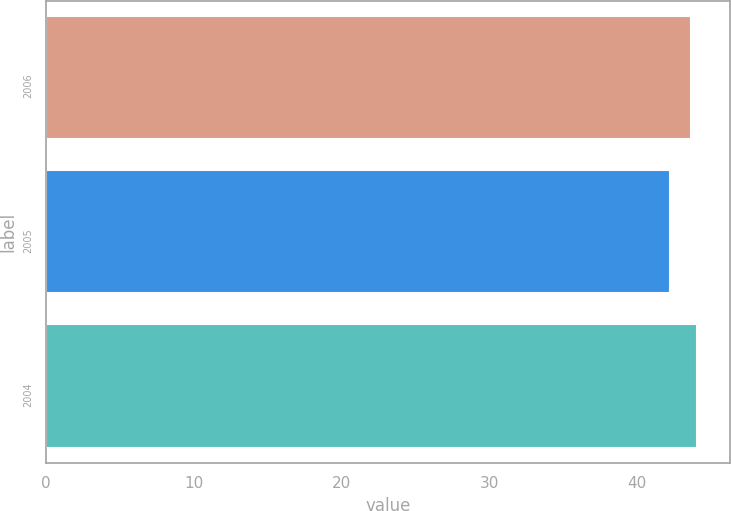<chart> <loc_0><loc_0><loc_500><loc_500><bar_chart><fcel>2006<fcel>2005<fcel>2004<nl><fcel>43.7<fcel>42.27<fcel>44.1<nl></chart> 